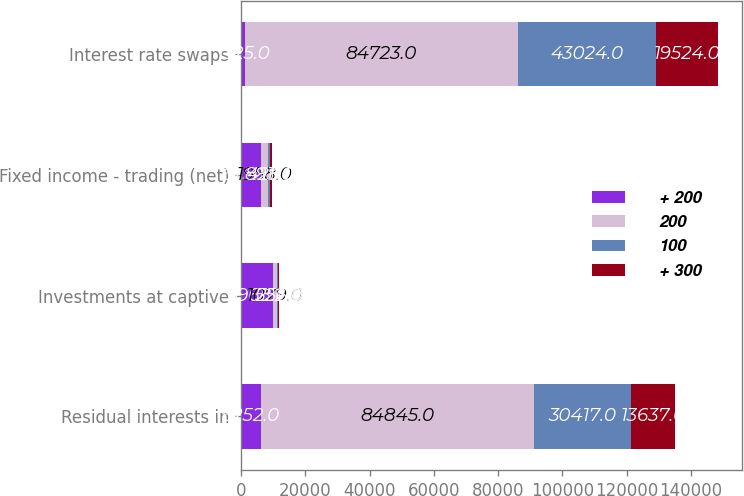Convert chart to OTSL. <chart><loc_0><loc_0><loc_500><loc_500><stacked_bar_chart><ecel><fcel>Residual interests in<fcel>Investments at captive<fcel>Fixed income - trading (net)<fcel>Interest rate swaps<nl><fcel>+ 200<fcel>6252<fcel>9968<fcel>6252<fcel>1325<nl><fcel>200<fcel>84845<fcel>1079<fcel>1958<fcel>84723<nl><fcel>100<fcel>30417<fcel>522<fcel>893<fcel>43024<nl><fcel>+ 300<fcel>13637<fcel>256<fcel>426<fcel>19524<nl></chart> 